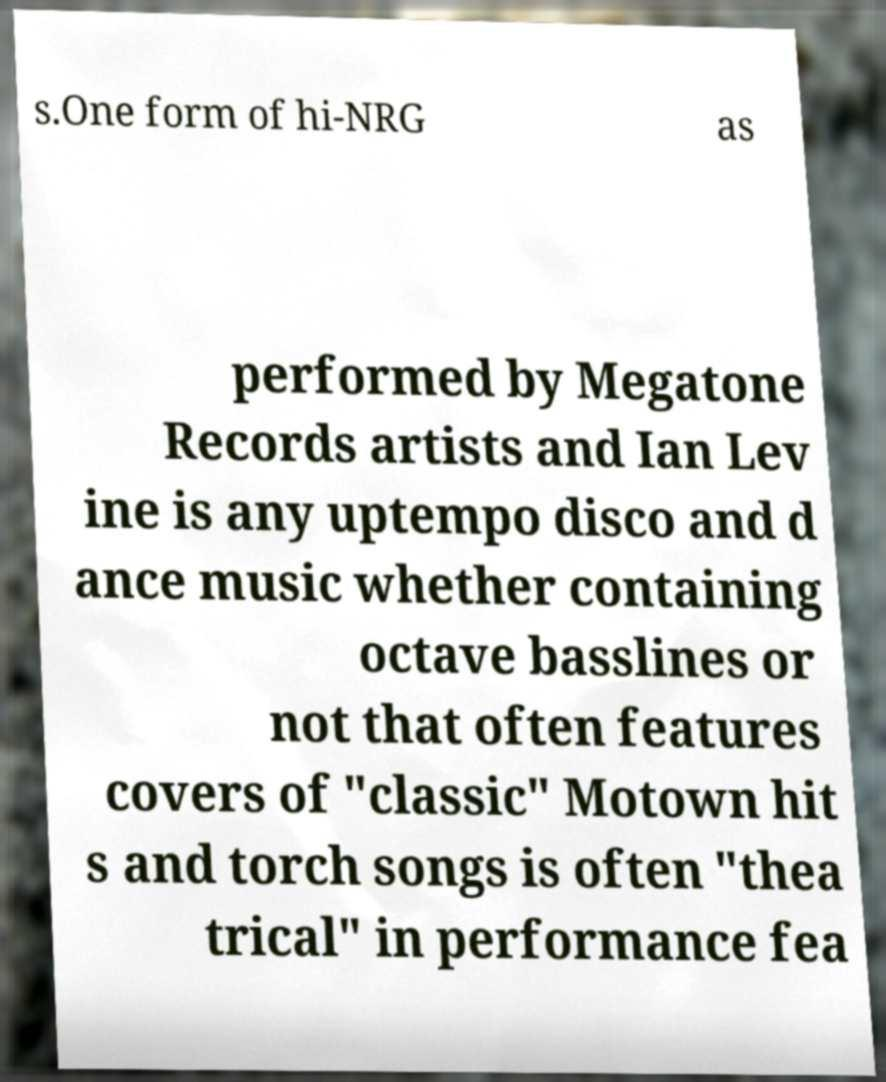Can you accurately transcribe the text from the provided image for me? s.One form of hi-NRG as performed by Megatone Records artists and Ian Lev ine is any uptempo disco and d ance music whether containing octave basslines or not that often features covers of "classic" Motown hit s and torch songs is often "thea trical" in performance fea 